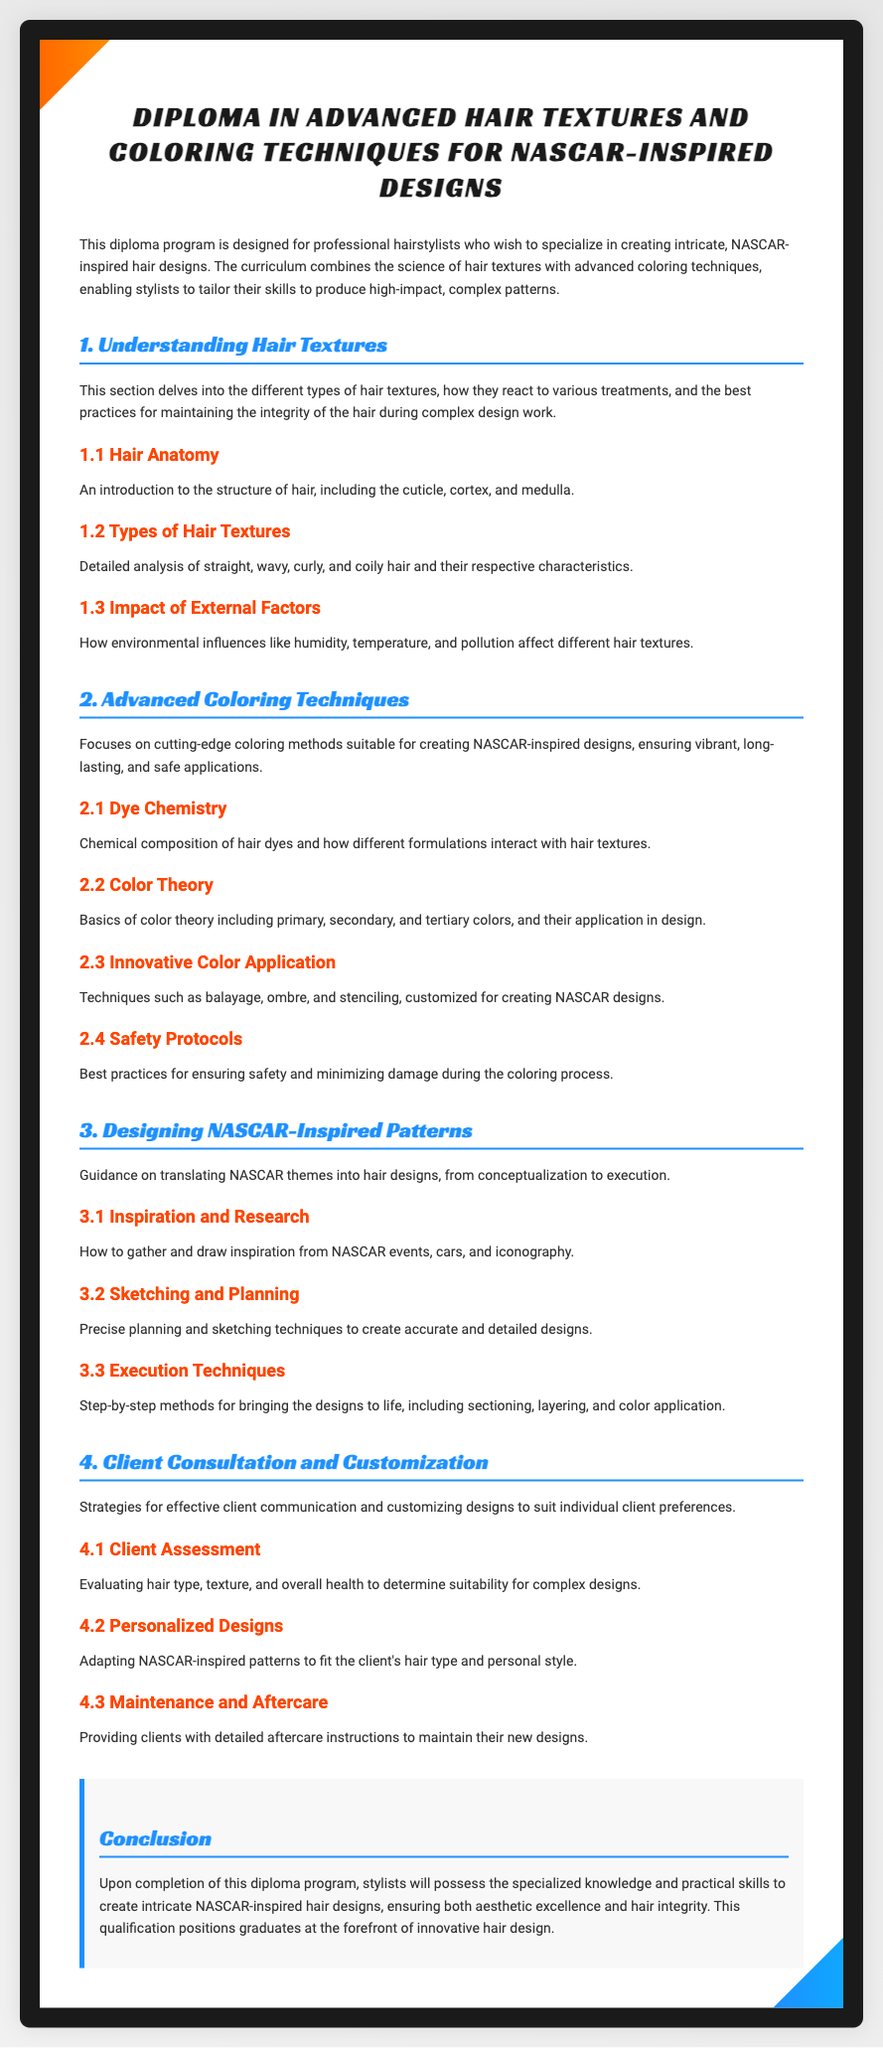What is the title of the diploma? The title of the diploma is stated in the header of the document, which specifies the focus of the program.
Answer: Diploma in Advanced Hair Textures and Coloring Techniques for NASCAR-Inspired Designs What is covered in Section 1 of the diploma? Section 1 discusses understanding hair textures, including anatomy and types of hair textures.
Answer: Understanding Hair Textures How many advanced coloring techniques are mentioned in Section 2? Section 2 outlines various advanced coloring techniques suitable for NASCAR-inspired designs, including dye chemistry and color theory.
Answer: Four What does the "Client Assessment" section focus on? The "Client Assessment" section is about evaluating the client's hair type, texture, and health.
Answer: Evaluating hair type, texture, and overall health What are the two key aspects of hair that the diploma emphasizes? The diploma emphasizes the science of hair textures and advanced coloring techniques, essential for intricate designs.
Answer: Hair textures and coloring techniques What is the purpose of the document? The purpose of the document is outlined in the introduction and specifies the intended audience and content focus.
Answer: To specialize in creating intricate, NASCAR-inspired hair designs What is the concluding focus of the diploma program? The conclusion highlights the outcomes and skills graduates will possess after completing the program.
Answer: Specialized knowledge and practical skills What is one of the techniques mentioned under "Innovative Color Application"? This section lists specific techniques for coloring that are suitable for the desired designs.
Answer: Balayage 